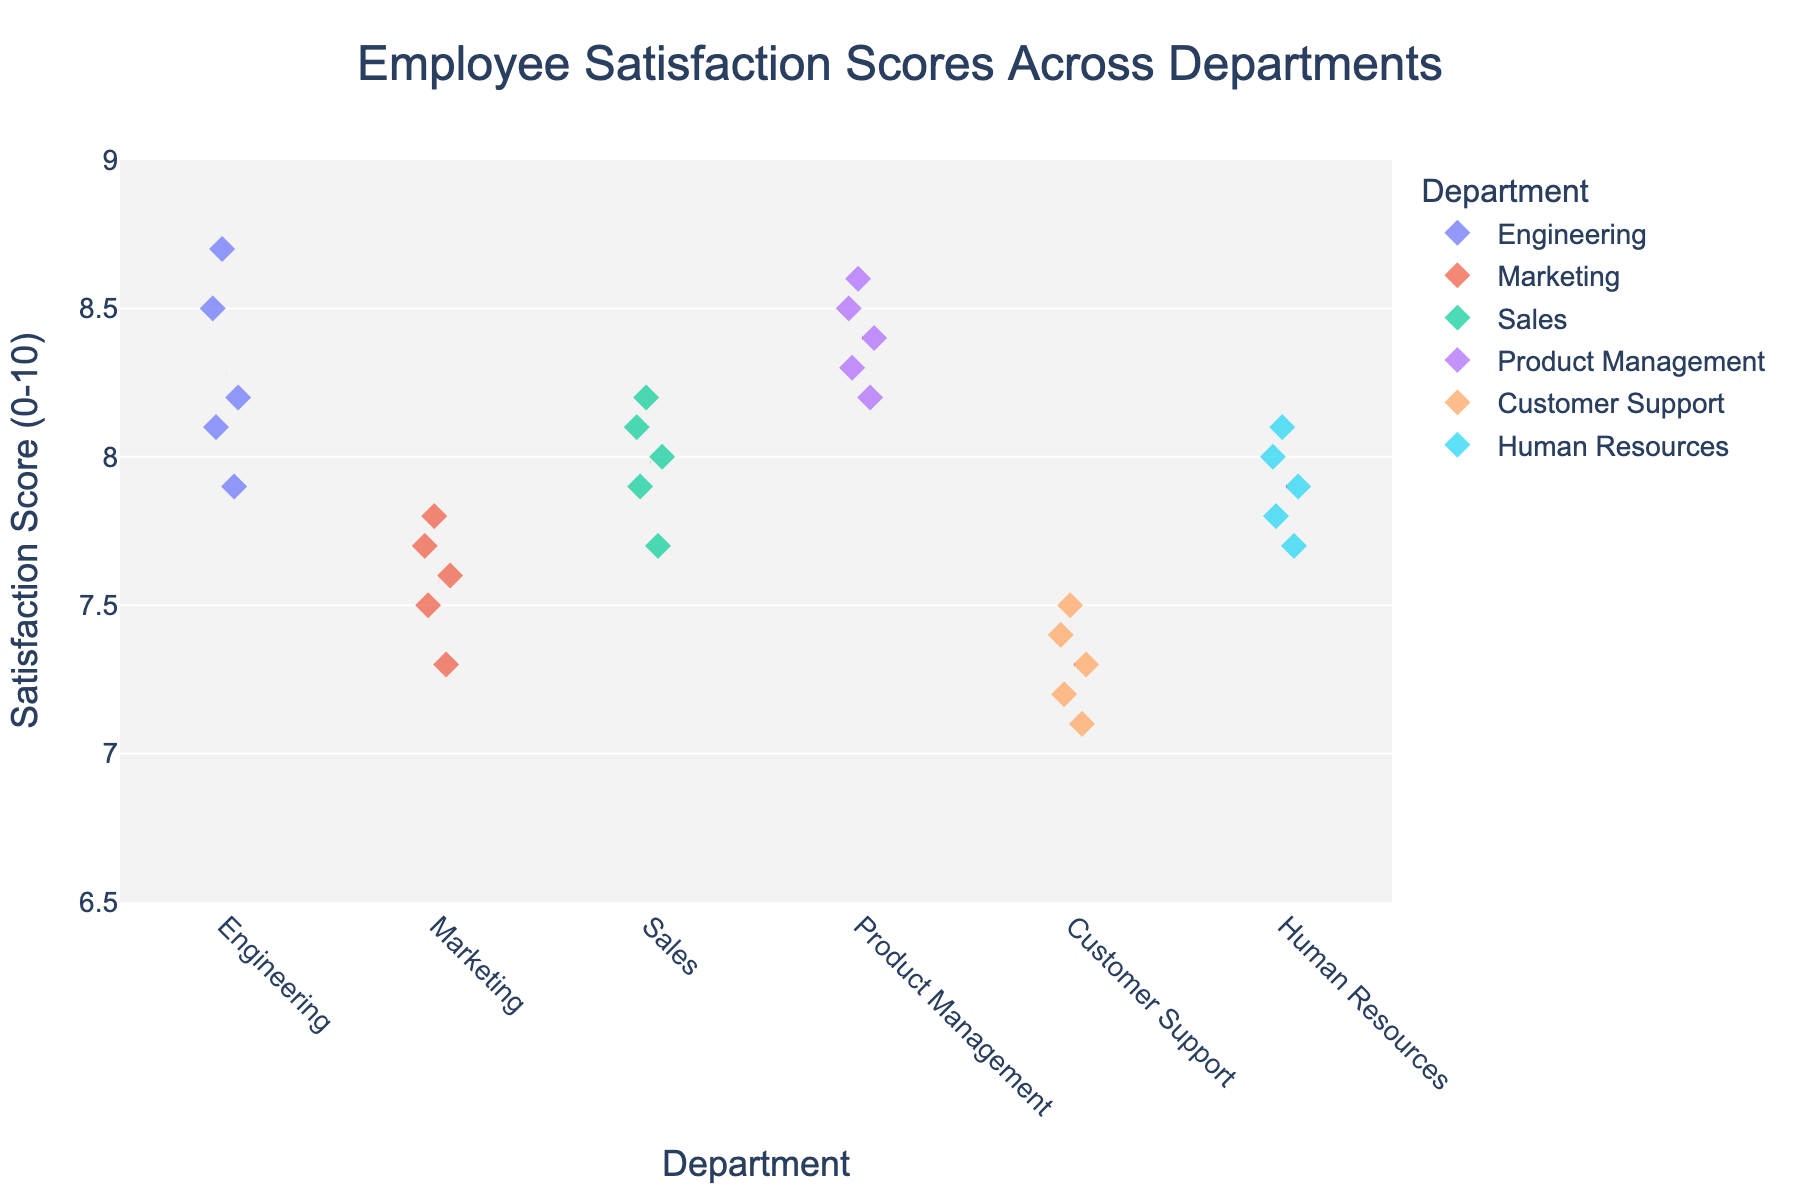Is there a title for the figure and what does it indicate? The figure has a title at the top which reads "Employee Satisfaction Scores Across Departments." This title indicates that the figure is showing employee satisfaction scores for different departments in the tech company.
Answer: Yes, it shows employee satisfaction scores across departments Which department has the highest average satisfaction score? The average satisfaction score for each department can be found by looking at the red dashed lines representing the mean scores. The department with the highest average satisfaction score has the red dashed line at the highest vertical position.
Answer: Product Management What is the range of the satisfaction scores for the Marketing department? To find the range, locate the highest and lowest satisfaction scores for the Marketing department from the strip plot. Marketing scores range from about 7.3 to 7.8. Subtract the lowest score from the highest score.
Answer: 0.5 Which department has the most dispersed satisfaction scores? To determine the department with the most dispersed scores, look at the spread of dots within each department's stripe. The wider the spread, the more dispersed the scores are.
Answer: Customer Support How does the highest satisfaction score in Customer Support compare to the lowest in Engineering? Find the highest score in Customer Support and the lowest in Engineering on the vertical axis. The highest in Customer Support is around 7.5 and the lowest in Engineering is around 7.9. Compare these two values.
Answer: Lower What is the median satisfaction score for the Sales department? To find the median, list out the scores for the Sales department and find the middle value. For an even number of values, it's the average of the two middle values.
Answer: 8.0 Which department has the narrowest range of satisfaction scores? Identify the department with the smallest distance between its highest and lowest scores. Compare the spreads of dots within each department's stripe to determine this.
Answer: Human Resources What color represents the Engineering department in the plot? Each department is represented by a different color. Find the color associated with the Engineering department by checking the color-coded legend or the colored dots labeled "Engineering."
Answer: Blue Does any department have satisfaction scores above 9? Look at the y-axis and check if any department has dots above the 9 mark.
Answer: No How often do the satisfaction scores for Product Management and Customer Support overlap? Check the y-axis representation of satisfaction scores for both Product Management and Customer Support by comparing their ranges. Count the number of times these ranges intersect vertically.
Answer: Rarely 